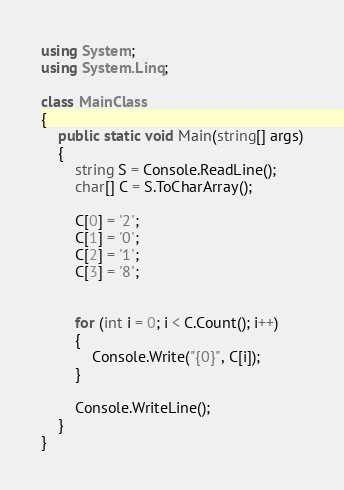Convert code to text. <code><loc_0><loc_0><loc_500><loc_500><_C#_>using System;
using System.Linq;

class MainClass
{
    public static void Main(string[] args)
    {
        string S = Console.ReadLine();
        char[] C = S.ToCharArray();

        C[0] = '2';
        C[1] = '0';
        C[2] = '1';
        C[3] = '8';


        for (int i = 0; i < C.Count(); i++)
        {
            Console.Write("{0}", C[i]);
        }

        Console.WriteLine();
    }
}
</code> 